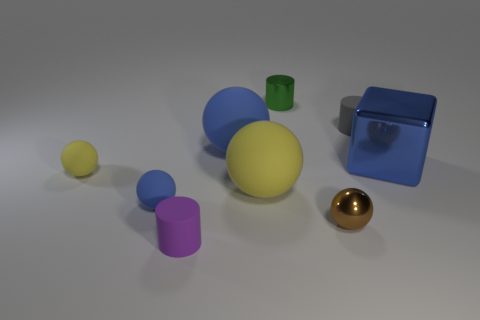Is the shape of the tiny object that is behind the gray matte cylinder the same as the shiny thing right of the tiny brown shiny sphere?
Ensure brevity in your answer.  No. How many tiny green metal things are behind the tiny yellow rubber sphere?
Your answer should be very brief. 1. Are there any purple objects made of the same material as the small green cylinder?
Your answer should be very brief. No. What is the material of the blue object that is the same size as the gray cylinder?
Keep it short and to the point. Rubber. Are the gray thing and the cube made of the same material?
Make the answer very short. No. How many things are either blue matte balls or green balls?
Provide a short and direct response. 2. The blue object left of the purple rubber cylinder has what shape?
Keep it short and to the point. Sphere. There is a cylinder that is the same material as the block; what is its color?
Offer a terse response. Green. There is a tiny purple object that is the same shape as the small gray matte thing; what is it made of?
Offer a terse response. Rubber. What is the shape of the large yellow thing?
Keep it short and to the point. Sphere. 